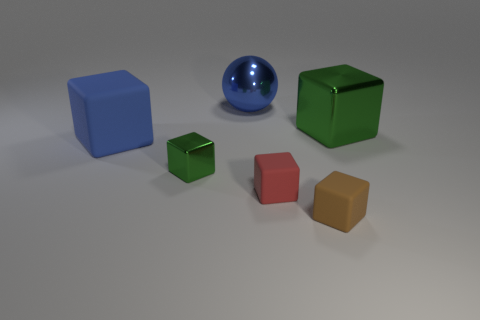What is the material of the small block to the right of the small matte block that is on the left side of the tiny brown matte object?
Offer a very short reply. Rubber. Does the large blue object that is in front of the large blue shiny thing have the same shape as the tiny green metallic thing?
Your answer should be very brief. Yes. What color is the other small block that is made of the same material as the tiny red block?
Your response must be concise. Brown. There is a tiny cube left of the red matte cube; what material is it?
Offer a very short reply. Metal. Does the large green object have the same shape as the rubber thing on the left side of the tiny green block?
Make the answer very short. Yes. What is the material of the cube that is both right of the red object and behind the brown rubber thing?
Offer a terse response. Metal. There is a ball that is the same size as the blue cube; what color is it?
Offer a terse response. Blue. Does the sphere have the same material as the red block left of the brown thing?
Your answer should be compact. No. What number of other things are there of the same size as the blue metallic object?
Your answer should be very brief. 2. Is there a large metallic sphere that is on the left side of the big blue thing that is to the right of the blue cube that is behind the tiny red cube?
Give a very brief answer. No. 